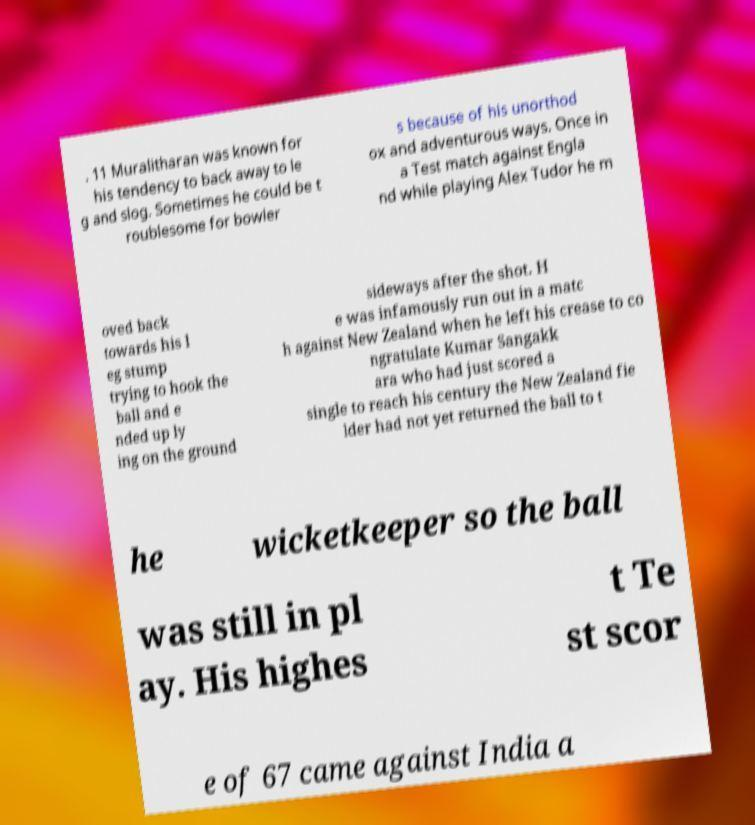Could you assist in decoding the text presented in this image and type it out clearly? . 11 Muralitharan was known for his tendency to back away to le g and slog. Sometimes he could be t roublesome for bowler s because of his unorthod ox and adventurous ways. Once in a Test match against Engla nd while playing Alex Tudor he m oved back towards his l eg stump trying to hook the ball and e nded up ly ing on the ground sideways after the shot. H e was infamously run out in a matc h against New Zealand when he left his crease to co ngratulate Kumar Sangakk ara who had just scored a single to reach his century the New Zealand fie lder had not yet returned the ball to t he wicketkeeper so the ball was still in pl ay. His highes t Te st scor e of 67 came against India a 